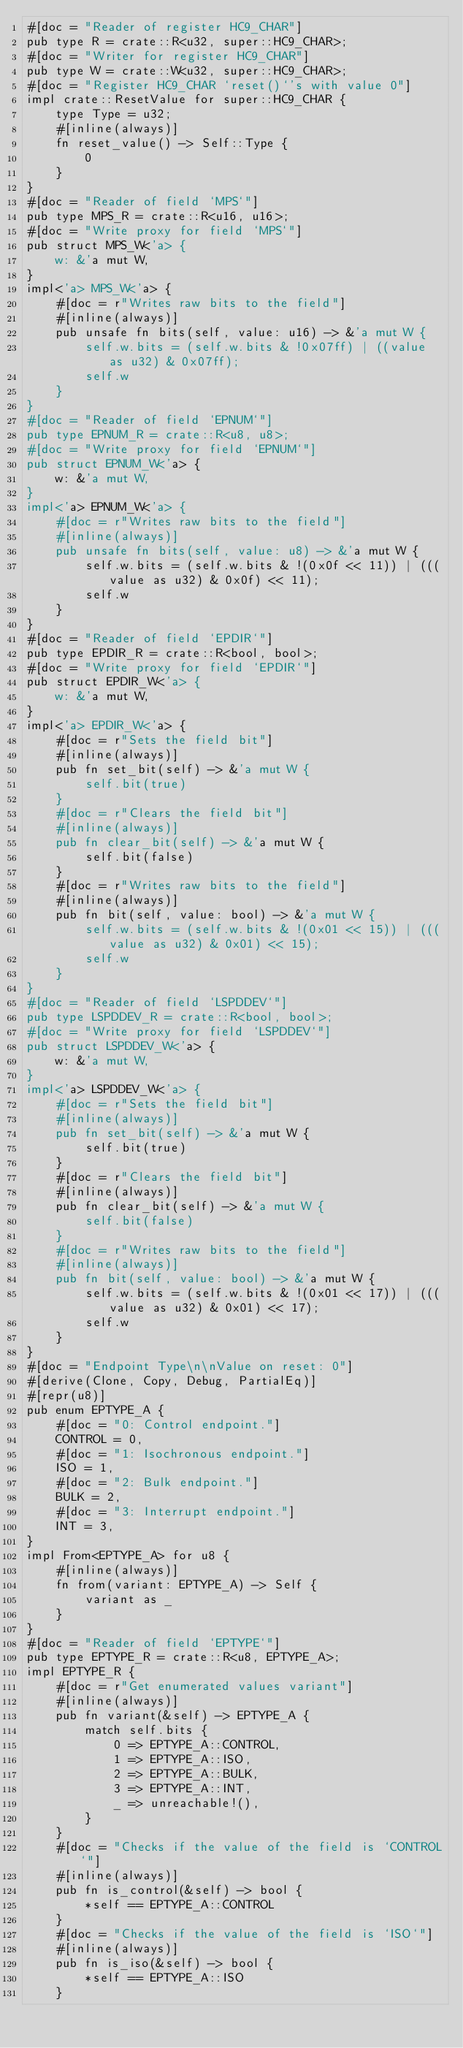<code> <loc_0><loc_0><loc_500><loc_500><_Rust_>#[doc = "Reader of register HC9_CHAR"]
pub type R = crate::R<u32, super::HC9_CHAR>;
#[doc = "Writer for register HC9_CHAR"]
pub type W = crate::W<u32, super::HC9_CHAR>;
#[doc = "Register HC9_CHAR `reset()`'s with value 0"]
impl crate::ResetValue for super::HC9_CHAR {
    type Type = u32;
    #[inline(always)]
    fn reset_value() -> Self::Type {
        0
    }
}
#[doc = "Reader of field `MPS`"]
pub type MPS_R = crate::R<u16, u16>;
#[doc = "Write proxy for field `MPS`"]
pub struct MPS_W<'a> {
    w: &'a mut W,
}
impl<'a> MPS_W<'a> {
    #[doc = r"Writes raw bits to the field"]
    #[inline(always)]
    pub unsafe fn bits(self, value: u16) -> &'a mut W {
        self.w.bits = (self.w.bits & !0x07ff) | ((value as u32) & 0x07ff);
        self.w
    }
}
#[doc = "Reader of field `EPNUM`"]
pub type EPNUM_R = crate::R<u8, u8>;
#[doc = "Write proxy for field `EPNUM`"]
pub struct EPNUM_W<'a> {
    w: &'a mut W,
}
impl<'a> EPNUM_W<'a> {
    #[doc = r"Writes raw bits to the field"]
    #[inline(always)]
    pub unsafe fn bits(self, value: u8) -> &'a mut W {
        self.w.bits = (self.w.bits & !(0x0f << 11)) | (((value as u32) & 0x0f) << 11);
        self.w
    }
}
#[doc = "Reader of field `EPDIR`"]
pub type EPDIR_R = crate::R<bool, bool>;
#[doc = "Write proxy for field `EPDIR`"]
pub struct EPDIR_W<'a> {
    w: &'a mut W,
}
impl<'a> EPDIR_W<'a> {
    #[doc = r"Sets the field bit"]
    #[inline(always)]
    pub fn set_bit(self) -> &'a mut W {
        self.bit(true)
    }
    #[doc = r"Clears the field bit"]
    #[inline(always)]
    pub fn clear_bit(self) -> &'a mut W {
        self.bit(false)
    }
    #[doc = r"Writes raw bits to the field"]
    #[inline(always)]
    pub fn bit(self, value: bool) -> &'a mut W {
        self.w.bits = (self.w.bits & !(0x01 << 15)) | (((value as u32) & 0x01) << 15);
        self.w
    }
}
#[doc = "Reader of field `LSPDDEV`"]
pub type LSPDDEV_R = crate::R<bool, bool>;
#[doc = "Write proxy for field `LSPDDEV`"]
pub struct LSPDDEV_W<'a> {
    w: &'a mut W,
}
impl<'a> LSPDDEV_W<'a> {
    #[doc = r"Sets the field bit"]
    #[inline(always)]
    pub fn set_bit(self) -> &'a mut W {
        self.bit(true)
    }
    #[doc = r"Clears the field bit"]
    #[inline(always)]
    pub fn clear_bit(self) -> &'a mut W {
        self.bit(false)
    }
    #[doc = r"Writes raw bits to the field"]
    #[inline(always)]
    pub fn bit(self, value: bool) -> &'a mut W {
        self.w.bits = (self.w.bits & !(0x01 << 17)) | (((value as u32) & 0x01) << 17);
        self.w
    }
}
#[doc = "Endpoint Type\n\nValue on reset: 0"]
#[derive(Clone, Copy, Debug, PartialEq)]
#[repr(u8)]
pub enum EPTYPE_A {
    #[doc = "0: Control endpoint."]
    CONTROL = 0,
    #[doc = "1: Isochronous endpoint."]
    ISO = 1,
    #[doc = "2: Bulk endpoint."]
    BULK = 2,
    #[doc = "3: Interrupt endpoint."]
    INT = 3,
}
impl From<EPTYPE_A> for u8 {
    #[inline(always)]
    fn from(variant: EPTYPE_A) -> Self {
        variant as _
    }
}
#[doc = "Reader of field `EPTYPE`"]
pub type EPTYPE_R = crate::R<u8, EPTYPE_A>;
impl EPTYPE_R {
    #[doc = r"Get enumerated values variant"]
    #[inline(always)]
    pub fn variant(&self) -> EPTYPE_A {
        match self.bits {
            0 => EPTYPE_A::CONTROL,
            1 => EPTYPE_A::ISO,
            2 => EPTYPE_A::BULK,
            3 => EPTYPE_A::INT,
            _ => unreachable!(),
        }
    }
    #[doc = "Checks if the value of the field is `CONTROL`"]
    #[inline(always)]
    pub fn is_control(&self) -> bool {
        *self == EPTYPE_A::CONTROL
    }
    #[doc = "Checks if the value of the field is `ISO`"]
    #[inline(always)]
    pub fn is_iso(&self) -> bool {
        *self == EPTYPE_A::ISO
    }</code> 